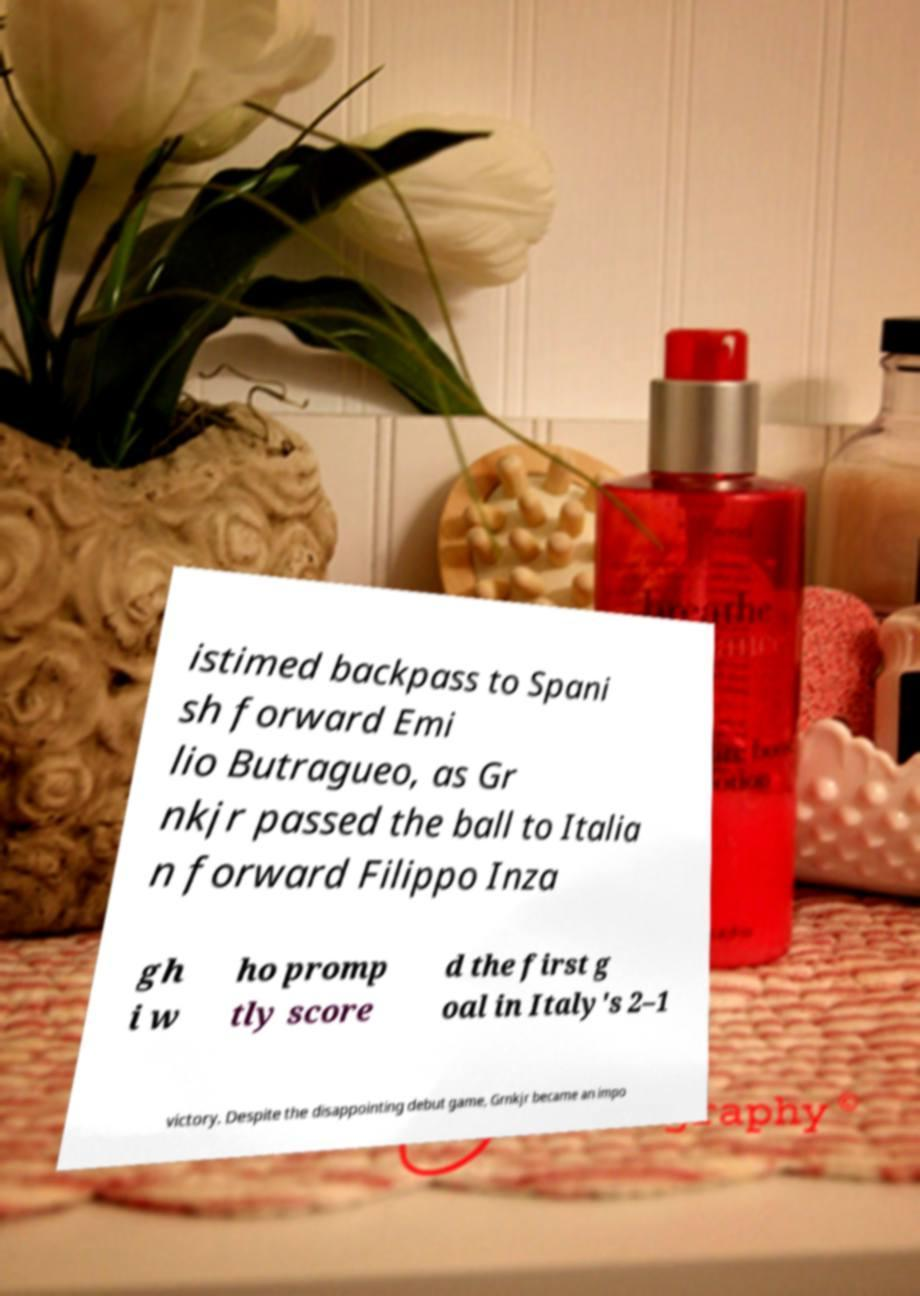For documentation purposes, I need the text within this image transcribed. Could you provide that? istimed backpass to Spani sh forward Emi lio Butragueo, as Gr nkjr passed the ball to Italia n forward Filippo Inza gh i w ho promp tly score d the first g oal in Italy's 2–1 victory. Despite the disappointing debut game, Grnkjr became an impo 